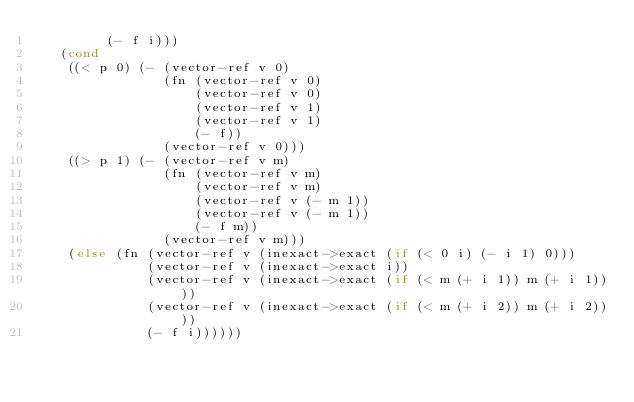Convert code to text. <code><loc_0><loc_0><loc_500><loc_500><_Scheme_>         (- f i)))
   (cond
    ((< p 0) (- (vector-ref v 0)
                (fn (vector-ref v 0)
                    (vector-ref v 0)
                    (vector-ref v 1)
                    (vector-ref v 1)
                    (- f))
                (vector-ref v 0)))
    ((> p 1) (- (vector-ref v m)
                (fn (vector-ref v m)
                    (vector-ref v m)
                    (vector-ref v (- m 1))
                    (vector-ref v (- m 1))
                    (- f m))
                (vector-ref v m)))
    (else (fn (vector-ref v (inexact->exact (if (< 0 i) (- i 1) 0)))
              (vector-ref v (inexact->exact i))
              (vector-ref v (inexact->exact (if (< m (+ i 1)) m (+ i 1))))
              (vector-ref v (inexact->exact (if (< m (+ i 2)) m (+ i 2))))
              (- f i))))))
</code> 